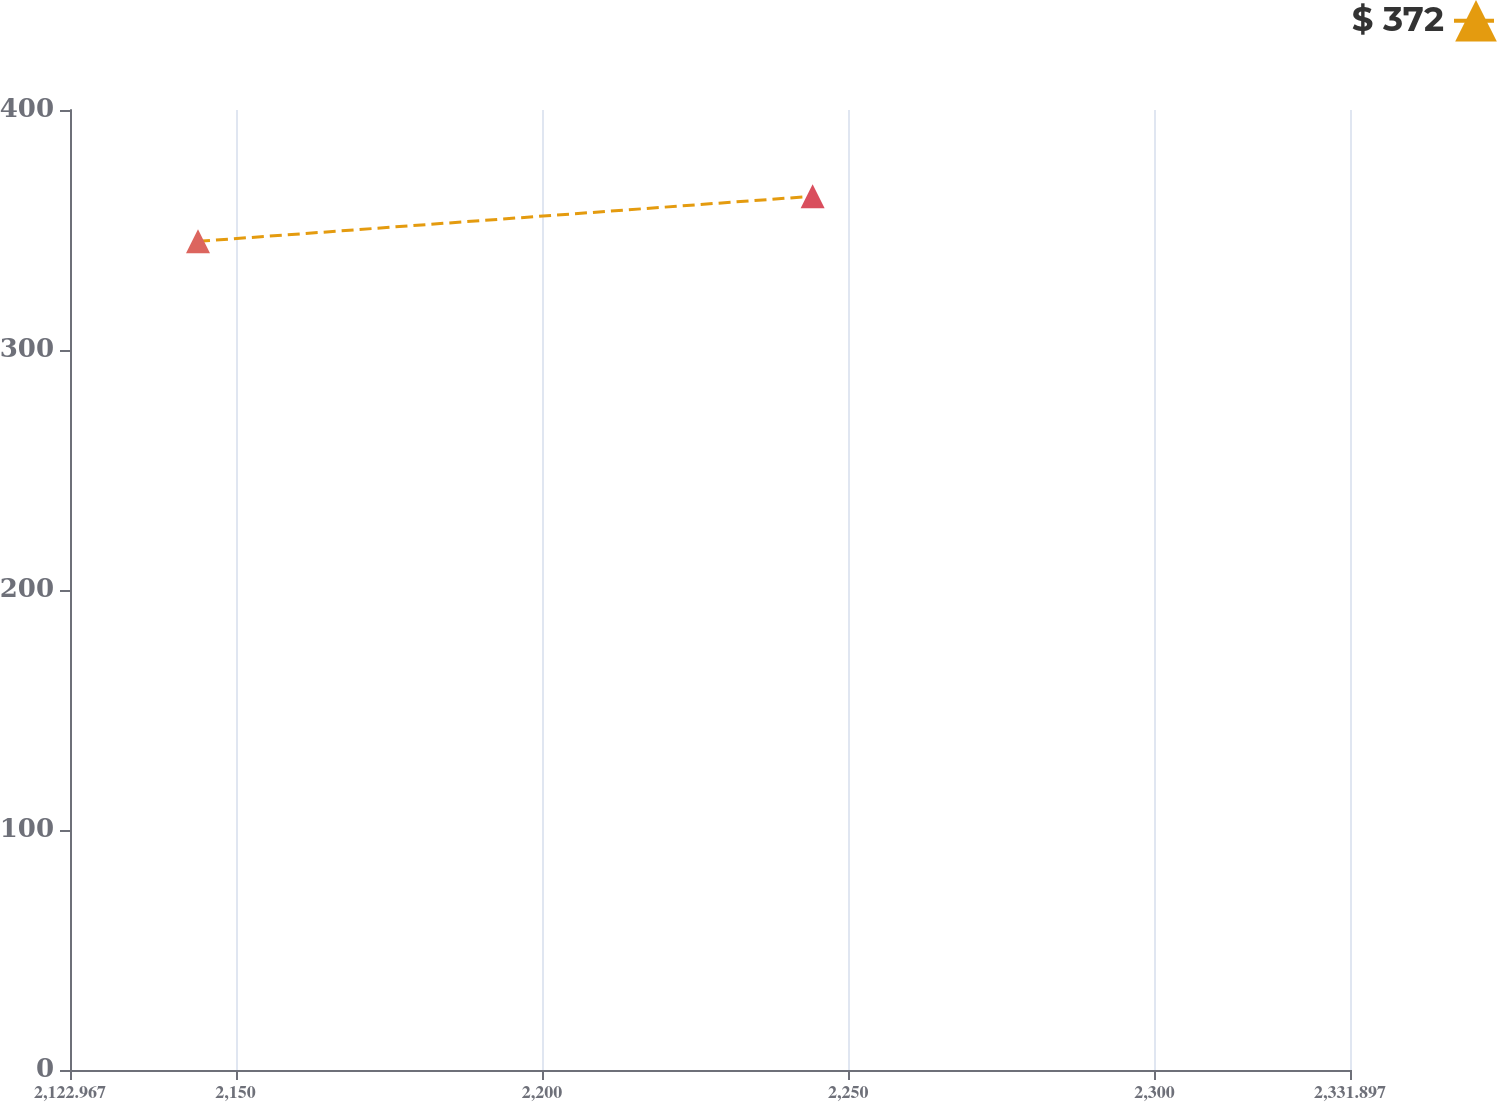Convert chart to OTSL. <chart><loc_0><loc_0><loc_500><loc_500><line_chart><ecel><fcel>$ 372<nl><fcel>2143.86<fcel>345.27<nl><fcel>2244.18<fcel>364.05<nl><fcel>2352.79<fcel>167.58<nl></chart> 